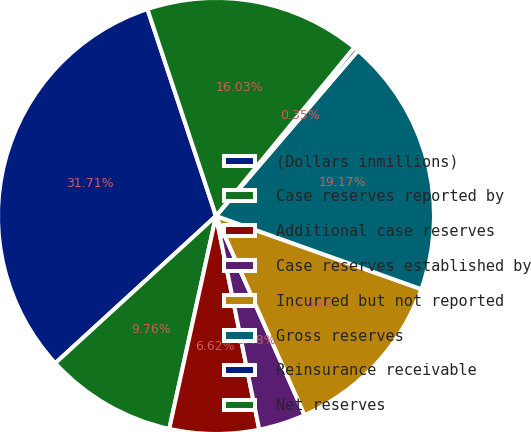Convert chart to OTSL. <chart><loc_0><loc_0><loc_500><loc_500><pie_chart><fcel>(Dollars inmillions)<fcel>Case reserves reported by<fcel>Additional case reserves<fcel>Case reserves established by<fcel>Incurred but not reported<fcel>Gross reserves<fcel>Reinsurance receivable<fcel>Net reserves<nl><fcel>31.71%<fcel>9.76%<fcel>6.62%<fcel>3.48%<fcel>12.89%<fcel>19.17%<fcel>0.35%<fcel>16.03%<nl></chart> 